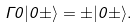<formula> <loc_0><loc_0><loc_500><loc_500>\Gamma 0 | 0 \pm \rangle = \pm | 0 \pm \rangle .</formula> 